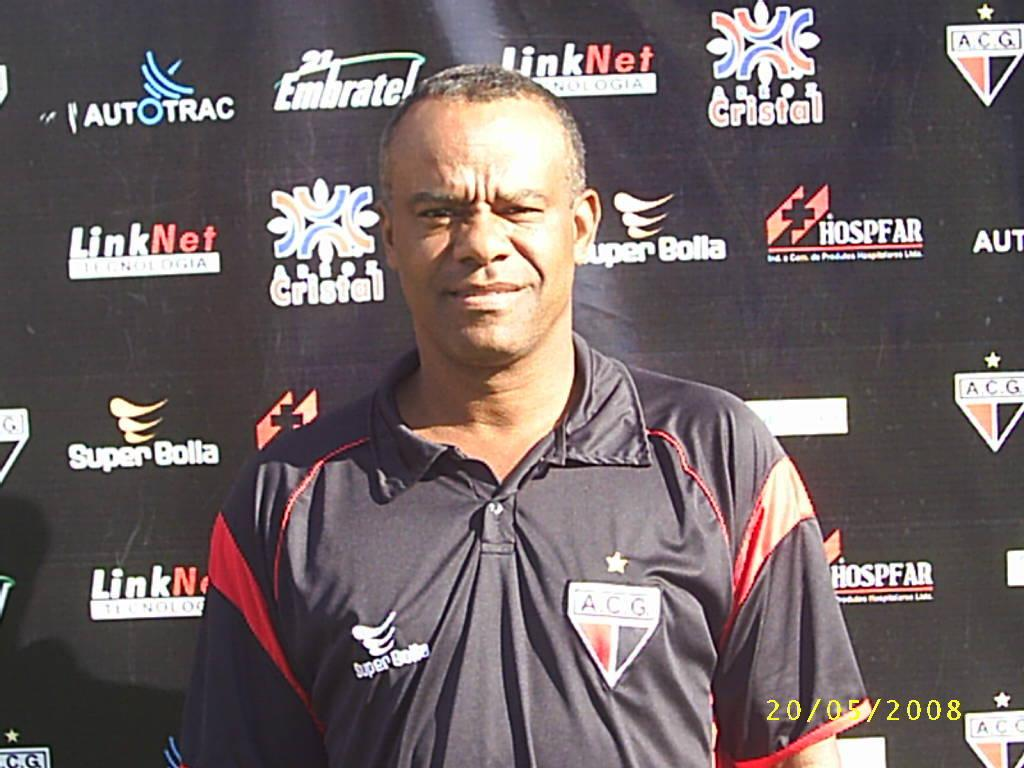<image>
Share a concise interpretation of the image provided. A man with an A C G patch on his shirt stands in front of a wall with Super Bolla ads on it. 